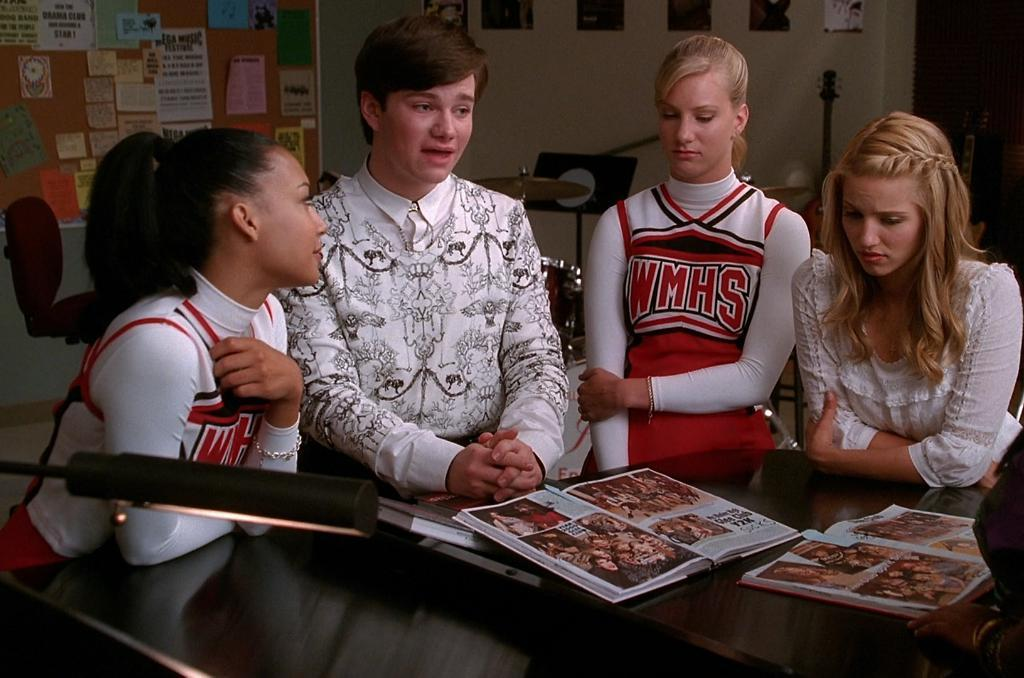<image>
Present a compact description of the photo's key features. Four people stand around a table looking at pictures wearing cheerleading outfits with WMHS on them. 